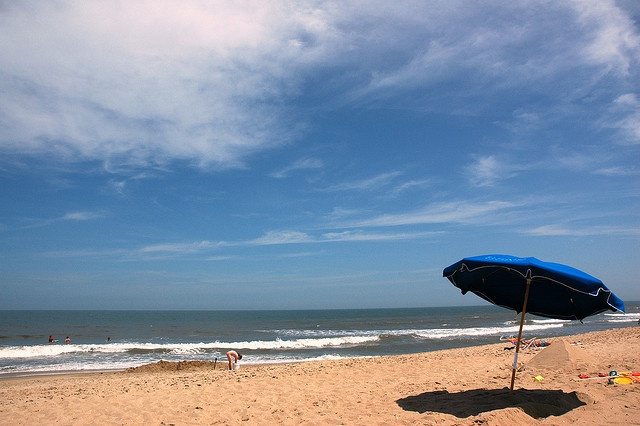Describe the objects in this image and their specific colors. I can see umbrella in darkgray, black, blue, gray, and navy tones, people in darkgray, maroon, ivory, brown, and salmon tones, people in darkgray, maroon, black, lightpink, and lightgray tones, people in darkgray, gray, black, and maroon tones, and people in darkgray, black, maroon, brown, and gray tones in this image. 